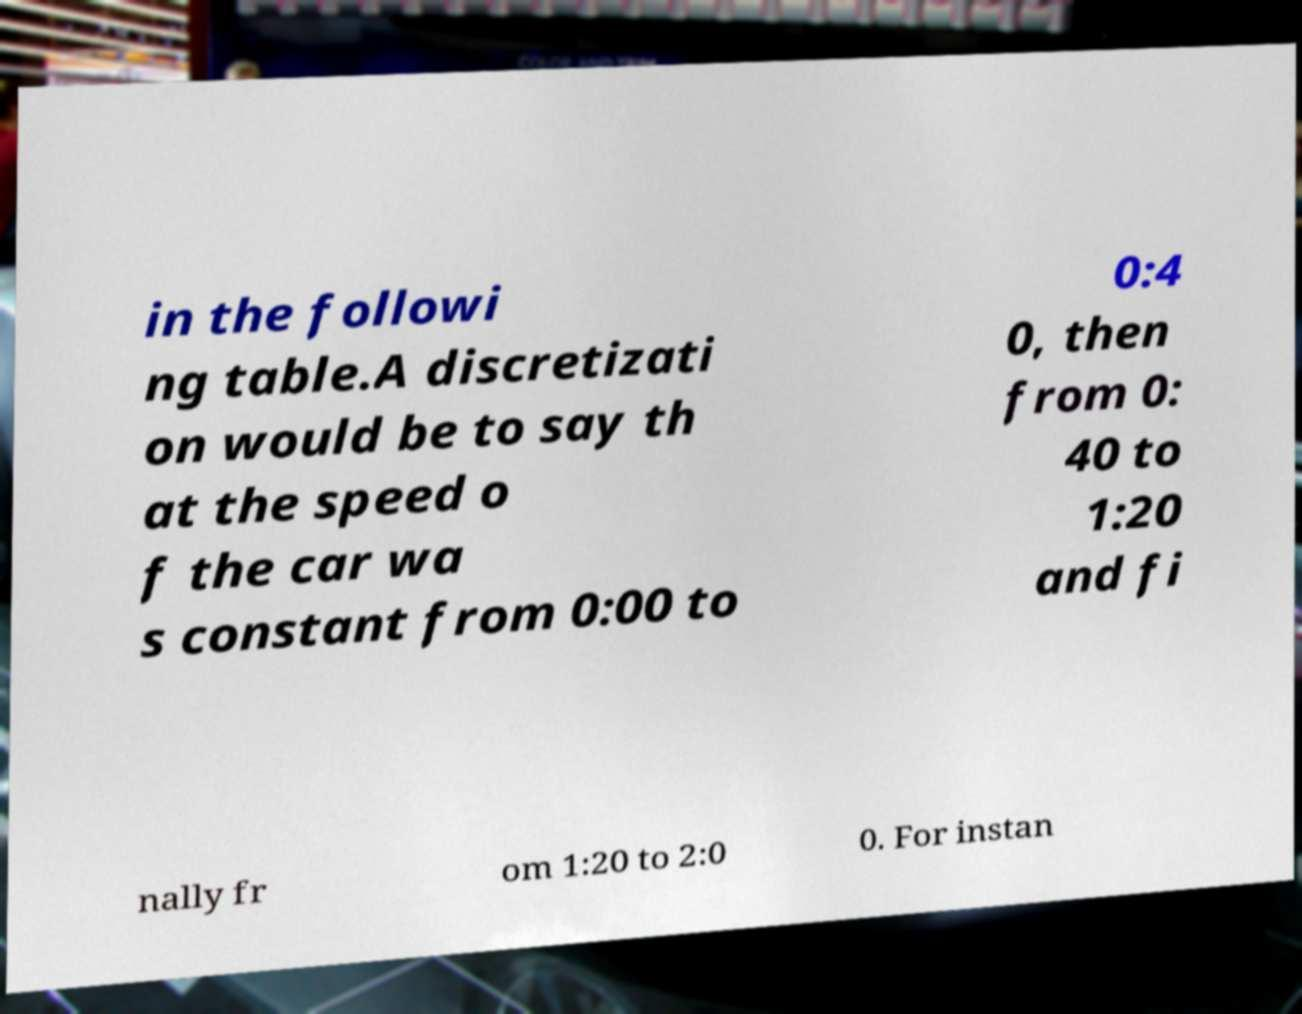Please read and relay the text visible in this image. What does it say? in the followi ng table.A discretizati on would be to say th at the speed o f the car wa s constant from 0:00 to 0:4 0, then from 0: 40 to 1:20 and fi nally fr om 1:20 to 2:0 0. For instan 